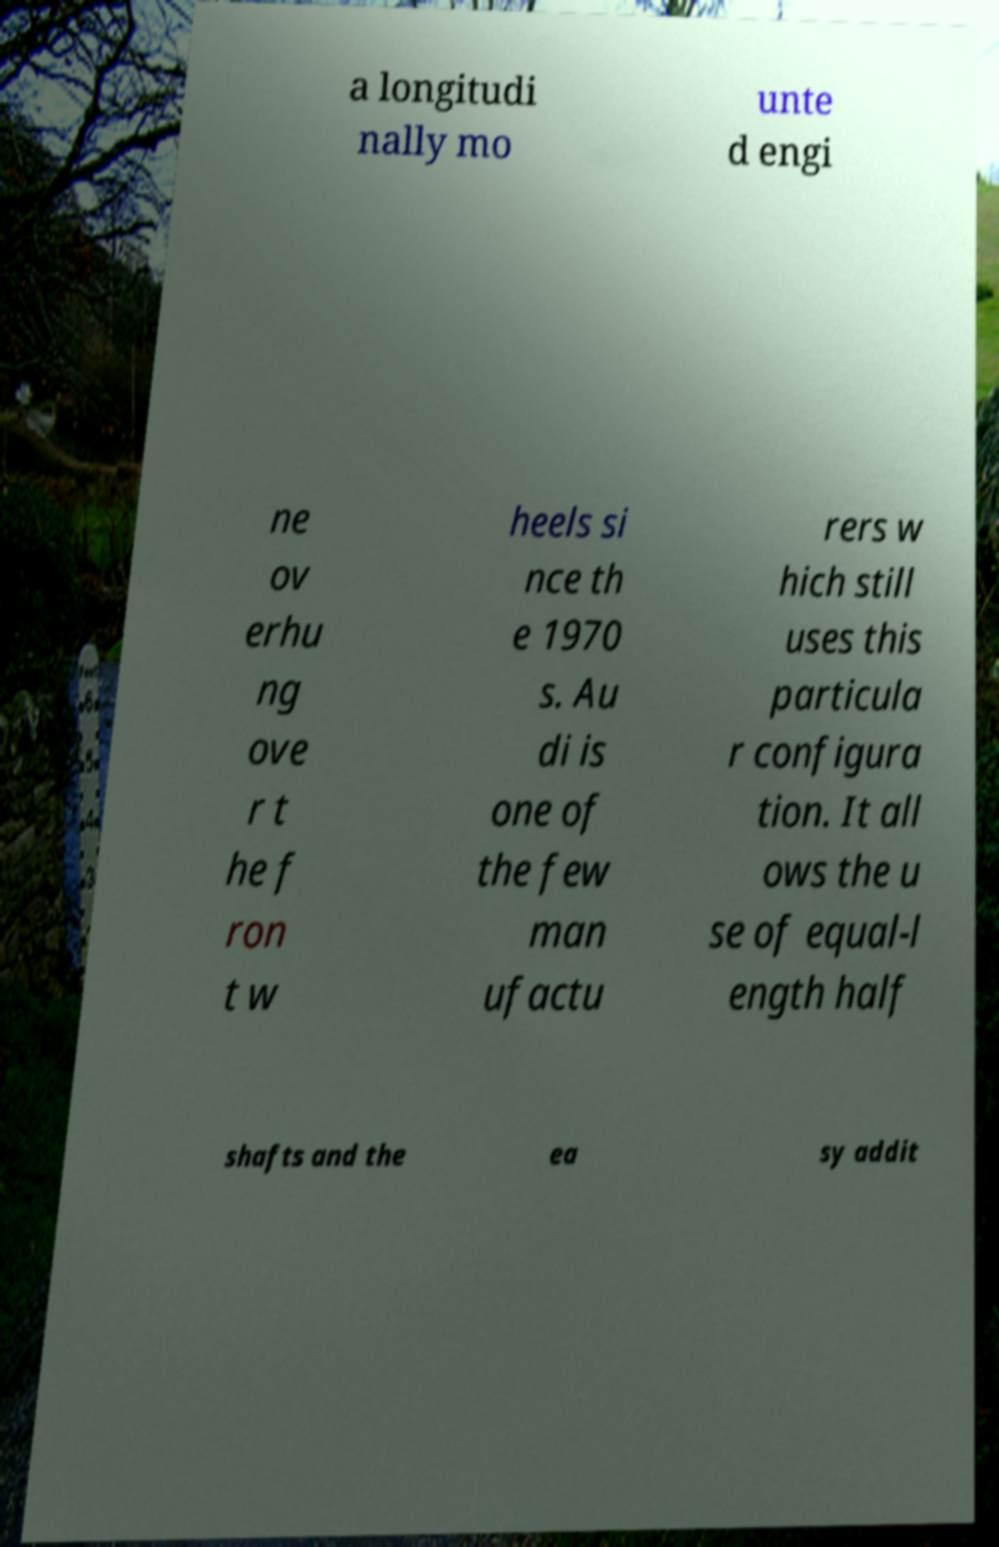Please read and relay the text visible in this image. What does it say? a longitudi nally mo unte d engi ne ov erhu ng ove r t he f ron t w heels si nce th e 1970 s. Au di is one of the few man ufactu rers w hich still uses this particula r configura tion. It all ows the u se of equal-l ength half shafts and the ea sy addit 